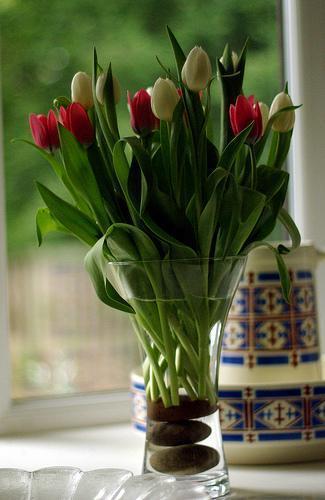How many rocks are there?
Give a very brief answer. 3. 